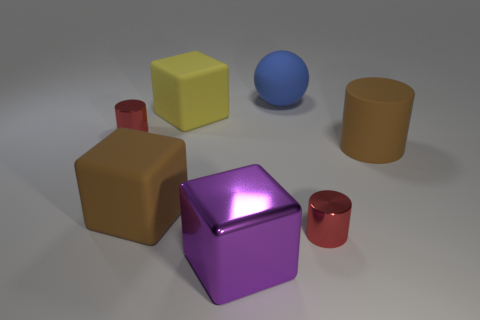Subtract all metallic blocks. How many blocks are left? 2 Add 2 large brown things. How many objects exist? 9 Subtract all yellow blocks. How many blocks are left? 2 Subtract all small brown blocks. Subtract all brown matte cylinders. How many objects are left? 6 Add 5 brown cylinders. How many brown cylinders are left? 6 Add 6 big yellow objects. How many big yellow objects exist? 7 Subtract 1 brown cubes. How many objects are left? 6 Subtract all balls. How many objects are left? 6 Subtract 1 cubes. How many cubes are left? 2 Subtract all green cubes. Subtract all green balls. How many cubes are left? 3 